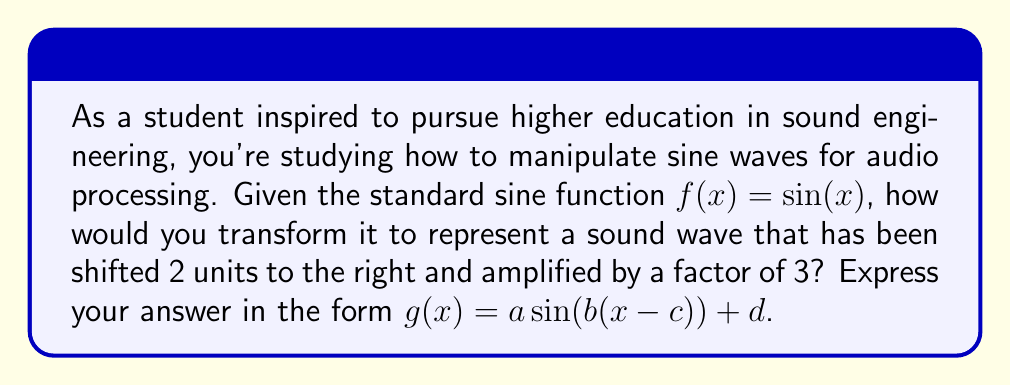Help me with this question. Let's approach this step-by-step:

1) The standard sine function is $f(x) = \sin(x)$.

2) To shift the function 2 units to the right, we replace $x$ with $(x - 2)$:
   $f(x) = \sin(x - 2)$

3) To amplify the wave by a factor of 3, we multiply the entire function by 3:
   $f(x) = 3\sin(x - 2)$

4) Comparing this to the general form $g(x) = a \sin(b(x - c)) + d$:
   - $a = 3$ (amplitude)
   - $b = 1$ (frequency, unchanged)
   - $c = 2$ (horizontal shift)
   - $d = 0$ (no vertical shift)

Therefore, the transformed function is:

$$g(x) = 3\sin(1(x - 2)) + 0$$

Which simplifies to:

$$g(x) = 3\sin(x - 2)$$
Answer: $g(x) = 3\sin(x - 2)$ 